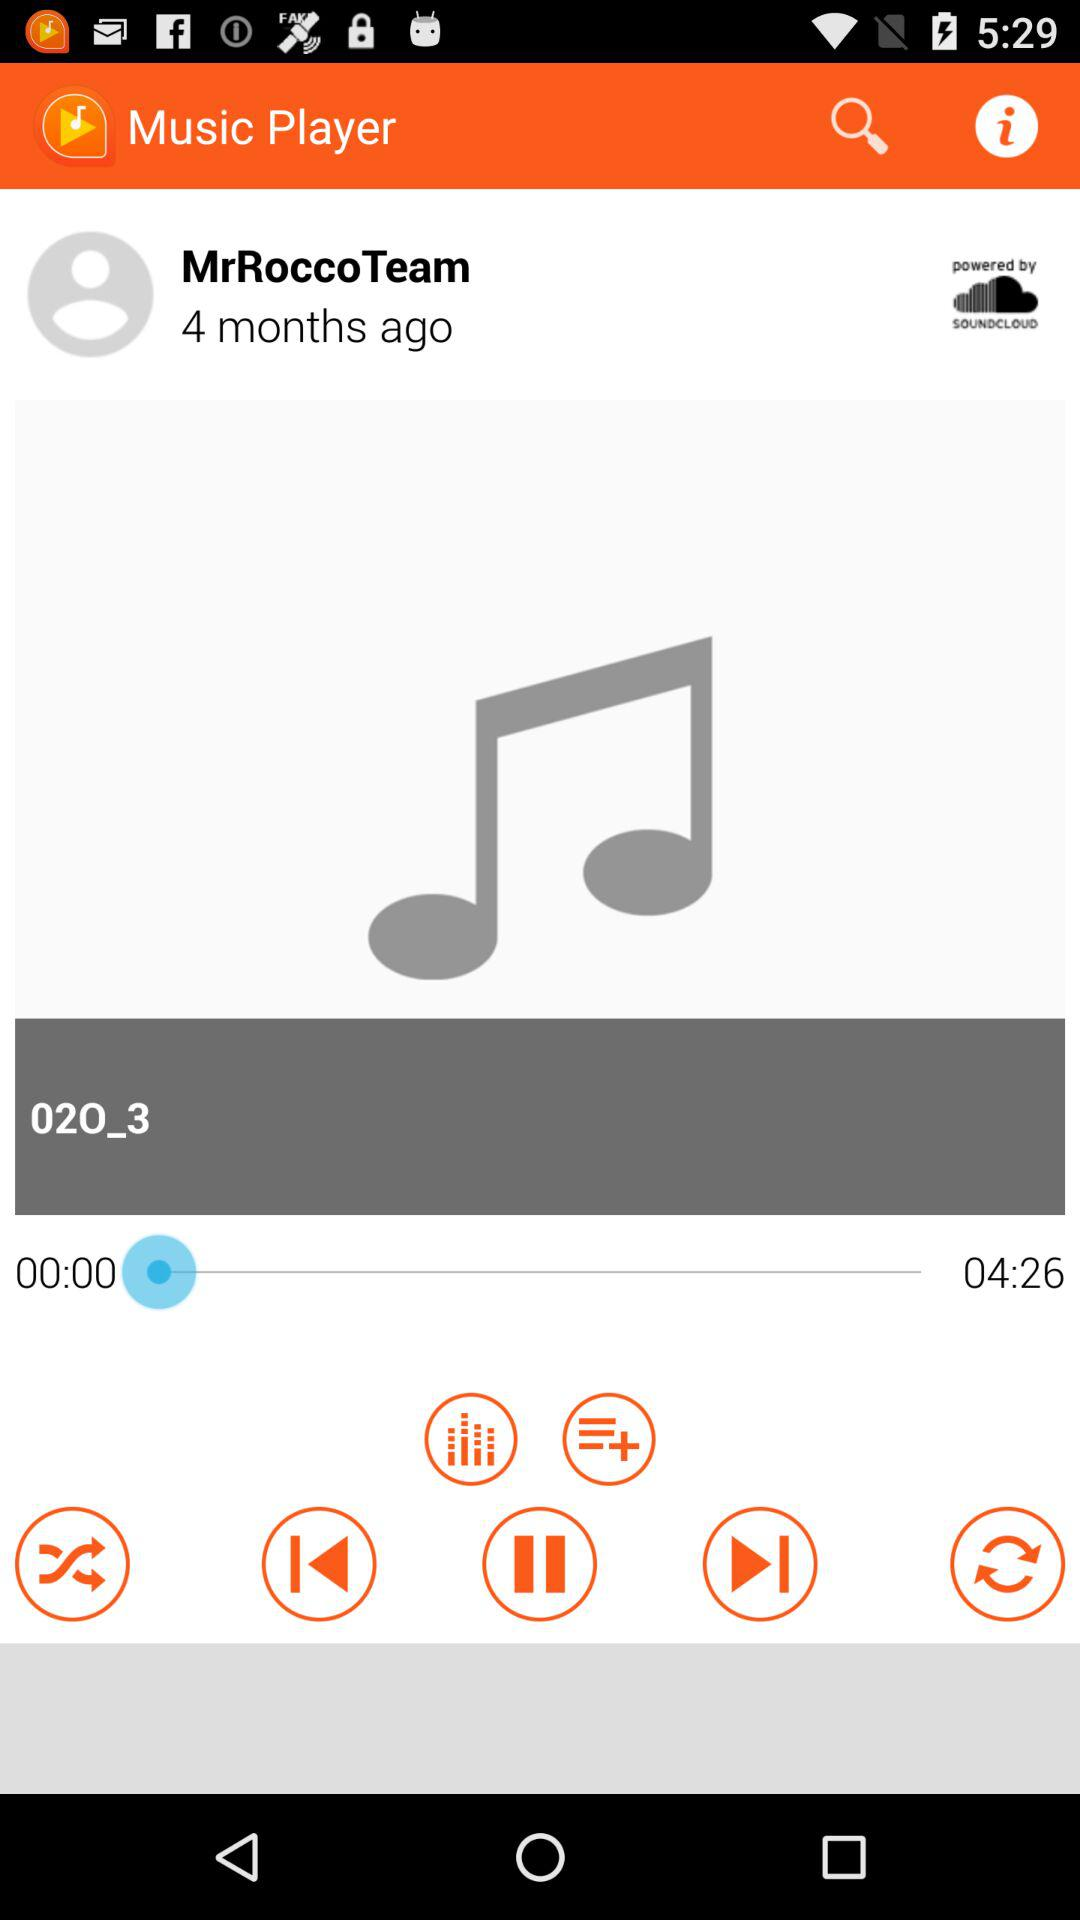What is the duration of the song which is playing? The duration of the song is 4 minutes 26 seconds. 